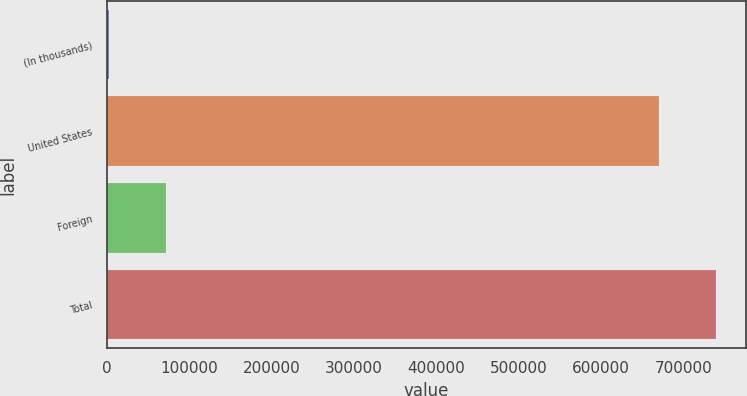Convert chart. <chart><loc_0><loc_0><loc_500><loc_500><bar_chart><fcel>(In thousands)<fcel>United States<fcel>Foreign<fcel>Total<nl><fcel>2008<fcel>669746<fcel>71605.7<fcel>739344<nl></chart> 